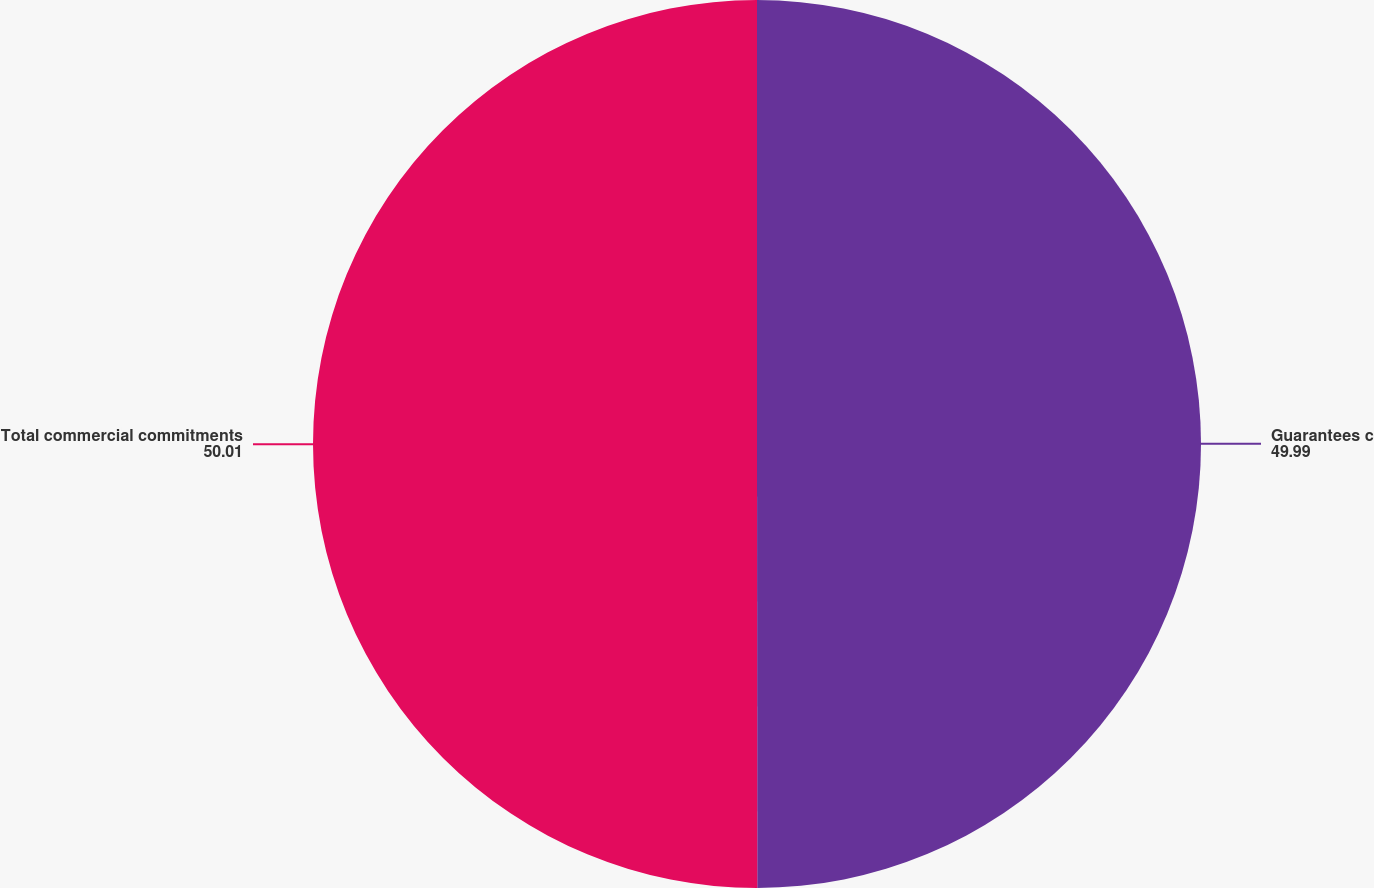Convert chart to OTSL. <chart><loc_0><loc_0><loc_500><loc_500><pie_chart><fcel>Guarantees c<fcel>Total commercial commitments<nl><fcel>49.99%<fcel>50.01%<nl></chart> 